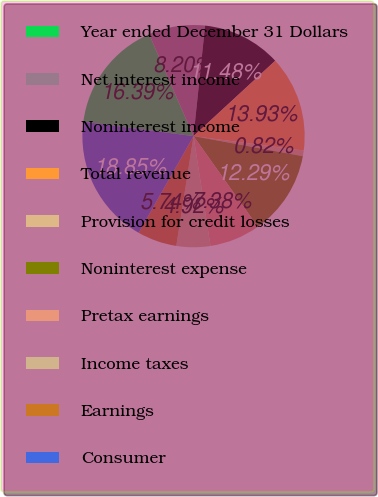Convert chart. <chart><loc_0><loc_0><loc_500><loc_500><pie_chart><fcel>Year ended December 31 Dollars<fcel>Net interest income<fcel>Noninterest income<fcel>Total revenue<fcel>Provision for credit losses<fcel>Noninterest expense<fcel>Pretax earnings<fcel>Income taxes<fcel>Earnings<fcel>Consumer<nl><fcel>16.39%<fcel>8.2%<fcel>11.48%<fcel>13.93%<fcel>0.82%<fcel>12.29%<fcel>7.38%<fcel>4.92%<fcel>5.74%<fcel>18.85%<nl></chart> 